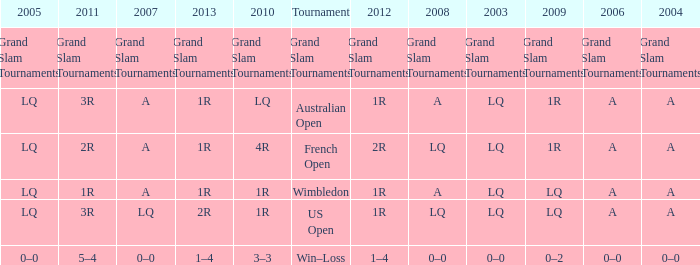Which year has a 2003 of lq? 1R, 1R, LQ, LQ. 